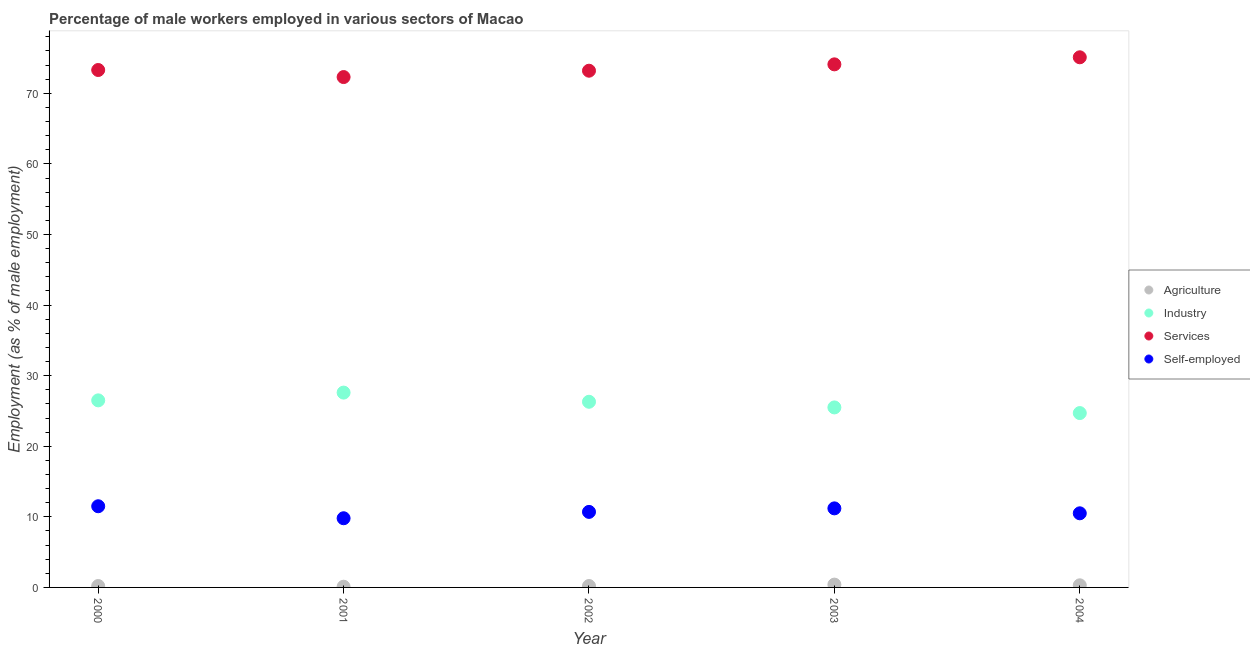How many different coloured dotlines are there?
Your answer should be compact. 4. Is the number of dotlines equal to the number of legend labels?
Give a very brief answer. Yes. What is the percentage of male workers in industry in 2002?
Your response must be concise. 26.3. Across all years, what is the maximum percentage of male workers in industry?
Provide a succinct answer. 27.6. Across all years, what is the minimum percentage of self employed male workers?
Offer a very short reply. 9.8. What is the total percentage of male workers in industry in the graph?
Keep it short and to the point. 130.6. What is the difference between the percentage of self employed male workers in 2001 and that in 2002?
Keep it short and to the point. -0.9. What is the difference between the percentage of self employed male workers in 2000 and the percentage of male workers in services in 2004?
Keep it short and to the point. -63.6. What is the average percentage of male workers in services per year?
Offer a very short reply. 73.6. In the year 2001, what is the difference between the percentage of self employed male workers and percentage of male workers in services?
Provide a short and direct response. -62.5. What is the ratio of the percentage of male workers in industry in 2003 to that in 2004?
Provide a short and direct response. 1.03. Is the percentage of self employed male workers in 2000 less than that in 2004?
Make the answer very short. No. Is the difference between the percentage of male workers in services in 2002 and 2003 greater than the difference between the percentage of self employed male workers in 2002 and 2003?
Give a very brief answer. No. What is the difference between the highest and the second highest percentage of male workers in services?
Provide a short and direct response. 1. What is the difference between the highest and the lowest percentage of male workers in agriculture?
Your answer should be compact. 0.3. Is it the case that in every year, the sum of the percentage of male workers in services and percentage of self employed male workers is greater than the sum of percentage of male workers in agriculture and percentage of male workers in industry?
Provide a short and direct response. Yes. Is the percentage of self employed male workers strictly greater than the percentage of male workers in services over the years?
Provide a short and direct response. No. How many dotlines are there?
Ensure brevity in your answer.  4. How many years are there in the graph?
Provide a succinct answer. 5. What is the difference between two consecutive major ticks on the Y-axis?
Provide a succinct answer. 10. Are the values on the major ticks of Y-axis written in scientific E-notation?
Make the answer very short. No. Does the graph contain any zero values?
Your response must be concise. No. How are the legend labels stacked?
Offer a very short reply. Vertical. What is the title of the graph?
Your response must be concise. Percentage of male workers employed in various sectors of Macao. Does "Goods and services" appear as one of the legend labels in the graph?
Your response must be concise. No. What is the label or title of the X-axis?
Your answer should be very brief. Year. What is the label or title of the Y-axis?
Make the answer very short. Employment (as % of male employment). What is the Employment (as % of male employment) in Agriculture in 2000?
Give a very brief answer. 0.2. What is the Employment (as % of male employment) of Industry in 2000?
Provide a succinct answer. 26.5. What is the Employment (as % of male employment) of Services in 2000?
Make the answer very short. 73.3. What is the Employment (as % of male employment) in Agriculture in 2001?
Keep it short and to the point. 0.1. What is the Employment (as % of male employment) of Industry in 2001?
Make the answer very short. 27.6. What is the Employment (as % of male employment) of Services in 2001?
Provide a short and direct response. 72.3. What is the Employment (as % of male employment) of Self-employed in 2001?
Offer a very short reply. 9.8. What is the Employment (as % of male employment) in Agriculture in 2002?
Provide a succinct answer. 0.2. What is the Employment (as % of male employment) in Industry in 2002?
Offer a very short reply. 26.3. What is the Employment (as % of male employment) in Services in 2002?
Offer a very short reply. 73.2. What is the Employment (as % of male employment) in Self-employed in 2002?
Your response must be concise. 10.7. What is the Employment (as % of male employment) in Agriculture in 2003?
Provide a short and direct response. 0.4. What is the Employment (as % of male employment) in Industry in 2003?
Your answer should be very brief. 25.5. What is the Employment (as % of male employment) in Services in 2003?
Your answer should be compact. 74.1. What is the Employment (as % of male employment) of Self-employed in 2003?
Keep it short and to the point. 11.2. What is the Employment (as % of male employment) in Agriculture in 2004?
Provide a succinct answer. 0.3. What is the Employment (as % of male employment) in Industry in 2004?
Your answer should be very brief. 24.7. What is the Employment (as % of male employment) in Services in 2004?
Your response must be concise. 75.1. Across all years, what is the maximum Employment (as % of male employment) in Agriculture?
Keep it short and to the point. 0.4. Across all years, what is the maximum Employment (as % of male employment) of Industry?
Provide a short and direct response. 27.6. Across all years, what is the maximum Employment (as % of male employment) of Services?
Provide a succinct answer. 75.1. Across all years, what is the minimum Employment (as % of male employment) of Agriculture?
Make the answer very short. 0.1. Across all years, what is the minimum Employment (as % of male employment) of Industry?
Offer a terse response. 24.7. Across all years, what is the minimum Employment (as % of male employment) of Services?
Keep it short and to the point. 72.3. Across all years, what is the minimum Employment (as % of male employment) of Self-employed?
Ensure brevity in your answer.  9.8. What is the total Employment (as % of male employment) of Industry in the graph?
Offer a very short reply. 130.6. What is the total Employment (as % of male employment) in Services in the graph?
Ensure brevity in your answer.  368. What is the total Employment (as % of male employment) in Self-employed in the graph?
Provide a succinct answer. 53.7. What is the difference between the Employment (as % of male employment) in Self-employed in 2000 and that in 2001?
Provide a succinct answer. 1.7. What is the difference between the Employment (as % of male employment) in Industry in 2000 and that in 2002?
Make the answer very short. 0.2. What is the difference between the Employment (as % of male employment) of Services in 2000 and that in 2002?
Give a very brief answer. 0.1. What is the difference between the Employment (as % of male employment) in Services in 2000 and that in 2003?
Ensure brevity in your answer.  -0.8. What is the difference between the Employment (as % of male employment) of Agriculture in 2000 and that in 2004?
Give a very brief answer. -0.1. What is the difference between the Employment (as % of male employment) of Industry in 2000 and that in 2004?
Provide a succinct answer. 1.8. What is the difference between the Employment (as % of male employment) in Services in 2000 and that in 2004?
Ensure brevity in your answer.  -1.8. What is the difference between the Employment (as % of male employment) in Industry in 2001 and that in 2002?
Your answer should be compact. 1.3. What is the difference between the Employment (as % of male employment) in Services in 2001 and that in 2002?
Your answer should be compact. -0.9. What is the difference between the Employment (as % of male employment) of Self-employed in 2001 and that in 2002?
Your response must be concise. -0.9. What is the difference between the Employment (as % of male employment) of Agriculture in 2001 and that in 2003?
Offer a very short reply. -0.3. What is the difference between the Employment (as % of male employment) of Industry in 2001 and that in 2003?
Ensure brevity in your answer.  2.1. What is the difference between the Employment (as % of male employment) of Self-employed in 2001 and that in 2003?
Your answer should be very brief. -1.4. What is the difference between the Employment (as % of male employment) in Industry in 2001 and that in 2004?
Ensure brevity in your answer.  2.9. What is the difference between the Employment (as % of male employment) in Agriculture in 2002 and that in 2003?
Your answer should be very brief. -0.2. What is the difference between the Employment (as % of male employment) of Self-employed in 2002 and that in 2003?
Offer a terse response. -0.5. What is the difference between the Employment (as % of male employment) in Agriculture in 2002 and that in 2004?
Offer a very short reply. -0.1. What is the difference between the Employment (as % of male employment) in Industry in 2003 and that in 2004?
Keep it short and to the point. 0.8. What is the difference between the Employment (as % of male employment) of Self-employed in 2003 and that in 2004?
Keep it short and to the point. 0.7. What is the difference between the Employment (as % of male employment) of Agriculture in 2000 and the Employment (as % of male employment) of Industry in 2001?
Give a very brief answer. -27.4. What is the difference between the Employment (as % of male employment) in Agriculture in 2000 and the Employment (as % of male employment) in Services in 2001?
Your answer should be compact. -72.1. What is the difference between the Employment (as % of male employment) in Industry in 2000 and the Employment (as % of male employment) in Services in 2001?
Offer a very short reply. -45.8. What is the difference between the Employment (as % of male employment) of Services in 2000 and the Employment (as % of male employment) of Self-employed in 2001?
Provide a succinct answer. 63.5. What is the difference between the Employment (as % of male employment) of Agriculture in 2000 and the Employment (as % of male employment) of Industry in 2002?
Your response must be concise. -26.1. What is the difference between the Employment (as % of male employment) in Agriculture in 2000 and the Employment (as % of male employment) in Services in 2002?
Offer a terse response. -73. What is the difference between the Employment (as % of male employment) of Industry in 2000 and the Employment (as % of male employment) of Services in 2002?
Give a very brief answer. -46.7. What is the difference between the Employment (as % of male employment) in Industry in 2000 and the Employment (as % of male employment) in Self-employed in 2002?
Provide a short and direct response. 15.8. What is the difference between the Employment (as % of male employment) in Services in 2000 and the Employment (as % of male employment) in Self-employed in 2002?
Provide a succinct answer. 62.6. What is the difference between the Employment (as % of male employment) of Agriculture in 2000 and the Employment (as % of male employment) of Industry in 2003?
Provide a succinct answer. -25.3. What is the difference between the Employment (as % of male employment) of Agriculture in 2000 and the Employment (as % of male employment) of Services in 2003?
Provide a succinct answer. -73.9. What is the difference between the Employment (as % of male employment) of Industry in 2000 and the Employment (as % of male employment) of Services in 2003?
Your answer should be very brief. -47.6. What is the difference between the Employment (as % of male employment) in Services in 2000 and the Employment (as % of male employment) in Self-employed in 2003?
Provide a succinct answer. 62.1. What is the difference between the Employment (as % of male employment) of Agriculture in 2000 and the Employment (as % of male employment) of Industry in 2004?
Offer a terse response. -24.5. What is the difference between the Employment (as % of male employment) in Agriculture in 2000 and the Employment (as % of male employment) in Services in 2004?
Give a very brief answer. -74.9. What is the difference between the Employment (as % of male employment) in Industry in 2000 and the Employment (as % of male employment) in Services in 2004?
Provide a succinct answer. -48.6. What is the difference between the Employment (as % of male employment) in Services in 2000 and the Employment (as % of male employment) in Self-employed in 2004?
Offer a very short reply. 62.8. What is the difference between the Employment (as % of male employment) of Agriculture in 2001 and the Employment (as % of male employment) of Industry in 2002?
Offer a terse response. -26.2. What is the difference between the Employment (as % of male employment) of Agriculture in 2001 and the Employment (as % of male employment) of Services in 2002?
Make the answer very short. -73.1. What is the difference between the Employment (as % of male employment) of Industry in 2001 and the Employment (as % of male employment) of Services in 2002?
Make the answer very short. -45.6. What is the difference between the Employment (as % of male employment) of Industry in 2001 and the Employment (as % of male employment) of Self-employed in 2002?
Your answer should be compact. 16.9. What is the difference between the Employment (as % of male employment) of Services in 2001 and the Employment (as % of male employment) of Self-employed in 2002?
Provide a succinct answer. 61.6. What is the difference between the Employment (as % of male employment) in Agriculture in 2001 and the Employment (as % of male employment) in Industry in 2003?
Make the answer very short. -25.4. What is the difference between the Employment (as % of male employment) in Agriculture in 2001 and the Employment (as % of male employment) in Services in 2003?
Your answer should be compact. -74. What is the difference between the Employment (as % of male employment) in Industry in 2001 and the Employment (as % of male employment) in Services in 2003?
Your answer should be compact. -46.5. What is the difference between the Employment (as % of male employment) of Services in 2001 and the Employment (as % of male employment) of Self-employed in 2003?
Your answer should be very brief. 61.1. What is the difference between the Employment (as % of male employment) of Agriculture in 2001 and the Employment (as % of male employment) of Industry in 2004?
Make the answer very short. -24.6. What is the difference between the Employment (as % of male employment) in Agriculture in 2001 and the Employment (as % of male employment) in Services in 2004?
Provide a short and direct response. -75. What is the difference between the Employment (as % of male employment) in Industry in 2001 and the Employment (as % of male employment) in Services in 2004?
Offer a terse response. -47.5. What is the difference between the Employment (as % of male employment) of Industry in 2001 and the Employment (as % of male employment) of Self-employed in 2004?
Offer a very short reply. 17.1. What is the difference between the Employment (as % of male employment) in Services in 2001 and the Employment (as % of male employment) in Self-employed in 2004?
Provide a succinct answer. 61.8. What is the difference between the Employment (as % of male employment) in Agriculture in 2002 and the Employment (as % of male employment) in Industry in 2003?
Provide a short and direct response. -25.3. What is the difference between the Employment (as % of male employment) in Agriculture in 2002 and the Employment (as % of male employment) in Services in 2003?
Offer a terse response. -73.9. What is the difference between the Employment (as % of male employment) of Industry in 2002 and the Employment (as % of male employment) of Services in 2003?
Keep it short and to the point. -47.8. What is the difference between the Employment (as % of male employment) in Services in 2002 and the Employment (as % of male employment) in Self-employed in 2003?
Ensure brevity in your answer.  62. What is the difference between the Employment (as % of male employment) in Agriculture in 2002 and the Employment (as % of male employment) in Industry in 2004?
Provide a succinct answer. -24.5. What is the difference between the Employment (as % of male employment) of Agriculture in 2002 and the Employment (as % of male employment) of Services in 2004?
Provide a short and direct response. -74.9. What is the difference between the Employment (as % of male employment) in Industry in 2002 and the Employment (as % of male employment) in Services in 2004?
Make the answer very short. -48.8. What is the difference between the Employment (as % of male employment) of Services in 2002 and the Employment (as % of male employment) of Self-employed in 2004?
Offer a very short reply. 62.7. What is the difference between the Employment (as % of male employment) in Agriculture in 2003 and the Employment (as % of male employment) in Industry in 2004?
Ensure brevity in your answer.  -24.3. What is the difference between the Employment (as % of male employment) in Agriculture in 2003 and the Employment (as % of male employment) in Services in 2004?
Provide a succinct answer. -74.7. What is the difference between the Employment (as % of male employment) in Agriculture in 2003 and the Employment (as % of male employment) in Self-employed in 2004?
Give a very brief answer. -10.1. What is the difference between the Employment (as % of male employment) of Industry in 2003 and the Employment (as % of male employment) of Services in 2004?
Your answer should be compact. -49.6. What is the difference between the Employment (as % of male employment) of Services in 2003 and the Employment (as % of male employment) of Self-employed in 2004?
Give a very brief answer. 63.6. What is the average Employment (as % of male employment) of Agriculture per year?
Provide a succinct answer. 0.24. What is the average Employment (as % of male employment) in Industry per year?
Ensure brevity in your answer.  26.12. What is the average Employment (as % of male employment) in Services per year?
Keep it short and to the point. 73.6. What is the average Employment (as % of male employment) of Self-employed per year?
Provide a succinct answer. 10.74. In the year 2000, what is the difference between the Employment (as % of male employment) of Agriculture and Employment (as % of male employment) of Industry?
Provide a short and direct response. -26.3. In the year 2000, what is the difference between the Employment (as % of male employment) of Agriculture and Employment (as % of male employment) of Services?
Provide a succinct answer. -73.1. In the year 2000, what is the difference between the Employment (as % of male employment) in Agriculture and Employment (as % of male employment) in Self-employed?
Offer a terse response. -11.3. In the year 2000, what is the difference between the Employment (as % of male employment) of Industry and Employment (as % of male employment) of Services?
Your answer should be very brief. -46.8. In the year 2000, what is the difference between the Employment (as % of male employment) in Services and Employment (as % of male employment) in Self-employed?
Make the answer very short. 61.8. In the year 2001, what is the difference between the Employment (as % of male employment) in Agriculture and Employment (as % of male employment) in Industry?
Give a very brief answer. -27.5. In the year 2001, what is the difference between the Employment (as % of male employment) in Agriculture and Employment (as % of male employment) in Services?
Provide a succinct answer. -72.2. In the year 2001, what is the difference between the Employment (as % of male employment) of Industry and Employment (as % of male employment) of Services?
Give a very brief answer. -44.7. In the year 2001, what is the difference between the Employment (as % of male employment) in Services and Employment (as % of male employment) in Self-employed?
Offer a terse response. 62.5. In the year 2002, what is the difference between the Employment (as % of male employment) in Agriculture and Employment (as % of male employment) in Industry?
Provide a short and direct response. -26.1. In the year 2002, what is the difference between the Employment (as % of male employment) in Agriculture and Employment (as % of male employment) in Services?
Offer a very short reply. -73. In the year 2002, what is the difference between the Employment (as % of male employment) of Agriculture and Employment (as % of male employment) of Self-employed?
Offer a very short reply. -10.5. In the year 2002, what is the difference between the Employment (as % of male employment) in Industry and Employment (as % of male employment) in Services?
Offer a very short reply. -46.9. In the year 2002, what is the difference between the Employment (as % of male employment) of Industry and Employment (as % of male employment) of Self-employed?
Keep it short and to the point. 15.6. In the year 2002, what is the difference between the Employment (as % of male employment) of Services and Employment (as % of male employment) of Self-employed?
Your answer should be compact. 62.5. In the year 2003, what is the difference between the Employment (as % of male employment) in Agriculture and Employment (as % of male employment) in Industry?
Keep it short and to the point. -25.1. In the year 2003, what is the difference between the Employment (as % of male employment) of Agriculture and Employment (as % of male employment) of Services?
Offer a very short reply. -73.7. In the year 2003, what is the difference between the Employment (as % of male employment) in Agriculture and Employment (as % of male employment) in Self-employed?
Your answer should be compact. -10.8. In the year 2003, what is the difference between the Employment (as % of male employment) in Industry and Employment (as % of male employment) in Services?
Provide a succinct answer. -48.6. In the year 2003, what is the difference between the Employment (as % of male employment) in Industry and Employment (as % of male employment) in Self-employed?
Keep it short and to the point. 14.3. In the year 2003, what is the difference between the Employment (as % of male employment) of Services and Employment (as % of male employment) of Self-employed?
Provide a succinct answer. 62.9. In the year 2004, what is the difference between the Employment (as % of male employment) in Agriculture and Employment (as % of male employment) in Industry?
Give a very brief answer. -24.4. In the year 2004, what is the difference between the Employment (as % of male employment) in Agriculture and Employment (as % of male employment) in Services?
Provide a succinct answer. -74.8. In the year 2004, what is the difference between the Employment (as % of male employment) in Agriculture and Employment (as % of male employment) in Self-employed?
Provide a short and direct response. -10.2. In the year 2004, what is the difference between the Employment (as % of male employment) of Industry and Employment (as % of male employment) of Services?
Keep it short and to the point. -50.4. In the year 2004, what is the difference between the Employment (as % of male employment) of Industry and Employment (as % of male employment) of Self-employed?
Offer a very short reply. 14.2. In the year 2004, what is the difference between the Employment (as % of male employment) of Services and Employment (as % of male employment) of Self-employed?
Provide a succinct answer. 64.6. What is the ratio of the Employment (as % of male employment) of Agriculture in 2000 to that in 2001?
Offer a terse response. 2. What is the ratio of the Employment (as % of male employment) in Industry in 2000 to that in 2001?
Give a very brief answer. 0.96. What is the ratio of the Employment (as % of male employment) of Services in 2000 to that in 2001?
Your answer should be very brief. 1.01. What is the ratio of the Employment (as % of male employment) in Self-employed in 2000 to that in 2001?
Your response must be concise. 1.17. What is the ratio of the Employment (as % of male employment) in Agriculture in 2000 to that in 2002?
Provide a succinct answer. 1. What is the ratio of the Employment (as % of male employment) in Industry in 2000 to that in 2002?
Your answer should be compact. 1.01. What is the ratio of the Employment (as % of male employment) in Services in 2000 to that in 2002?
Your response must be concise. 1. What is the ratio of the Employment (as % of male employment) of Self-employed in 2000 to that in 2002?
Your response must be concise. 1.07. What is the ratio of the Employment (as % of male employment) in Industry in 2000 to that in 2003?
Your answer should be very brief. 1.04. What is the ratio of the Employment (as % of male employment) in Services in 2000 to that in 2003?
Ensure brevity in your answer.  0.99. What is the ratio of the Employment (as % of male employment) in Self-employed in 2000 to that in 2003?
Keep it short and to the point. 1.03. What is the ratio of the Employment (as % of male employment) of Agriculture in 2000 to that in 2004?
Give a very brief answer. 0.67. What is the ratio of the Employment (as % of male employment) in Industry in 2000 to that in 2004?
Provide a short and direct response. 1.07. What is the ratio of the Employment (as % of male employment) in Self-employed in 2000 to that in 2004?
Offer a very short reply. 1.1. What is the ratio of the Employment (as % of male employment) in Industry in 2001 to that in 2002?
Keep it short and to the point. 1.05. What is the ratio of the Employment (as % of male employment) in Services in 2001 to that in 2002?
Offer a terse response. 0.99. What is the ratio of the Employment (as % of male employment) of Self-employed in 2001 to that in 2002?
Your answer should be compact. 0.92. What is the ratio of the Employment (as % of male employment) in Agriculture in 2001 to that in 2003?
Ensure brevity in your answer.  0.25. What is the ratio of the Employment (as % of male employment) of Industry in 2001 to that in 2003?
Ensure brevity in your answer.  1.08. What is the ratio of the Employment (as % of male employment) in Services in 2001 to that in 2003?
Your answer should be compact. 0.98. What is the ratio of the Employment (as % of male employment) of Industry in 2001 to that in 2004?
Your response must be concise. 1.12. What is the ratio of the Employment (as % of male employment) of Services in 2001 to that in 2004?
Offer a very short reply. 0.96. What is the ratio of the Employment (as % of male employment) in Agriculture in 2002 to that in 2003?
Offer a very short reply. 0.5. What is the ratio of the Employment (as % of male employment) in Industry in 2002 to that in 2003?
Your response must be concise. 1.03. What is the ratio of the Employment (as % of male employment) in Services in 2002 to that in 2003?
Your answer should be compact. 0.99. What is the ratio of the Employment (as % of male employment) in Self-employed in 2002 to that in 2003?
Offer a terse response. 0.96. What is the ratio of the Employment (as % of male employment) of Industry in 2002 to that in 2004?
Make the answer very short. 1.06. What is the ratio of the Employment (as % of male employment) in Services in 2002 to that in 2004?
Offer a terse response. 0.97. What is the ratio of the Employment (as % of male employment) of Self-employed in 2002 to that in 2004?
Offer a very short reply. 1.02. What is the ratio of the Employment (as % of male employment) in Industry in 2003 to that in 2004?
Your response must be concise. 1.03. What is the ratio of the Employment (as % of male employment) in Services in 2003 to that in 2004?
Offer a very short reply. 0.99. What is the ratio of the Employment (as % of male employment) of Self-employed in 2003 to that in 2004?
Provide a succinct answer. 1.07. What is the difference between the highest and the second highest Employment (as % of male employment) of Self-employed?
Provide a short and direct response. 0.3. What is the difference between the highest and the lowest Employment (as % of male employment) of Agriculture?
Your answer should be compact. 0.3. 